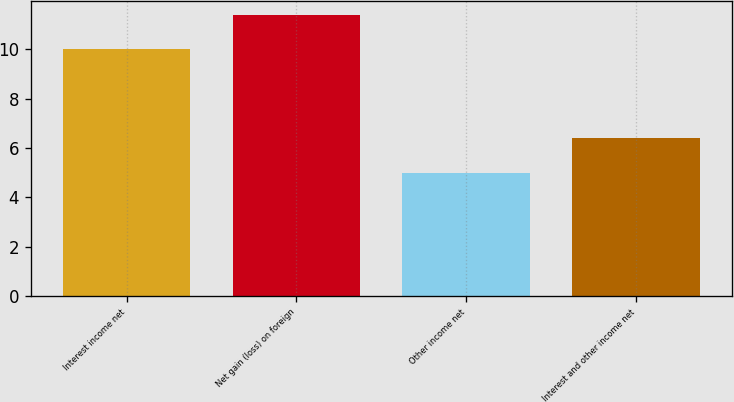<chart> <loc_0><loc_0><loc_500><loc_500><bar_chart><fcel>Interest income net<fcel>Net gain (loss) on foreign<fcel>Other income net<fcel>Interest and other income net<nl><fcel>10<fcel>11.4<fcel>5<fcel>6.4<nl></chart> 